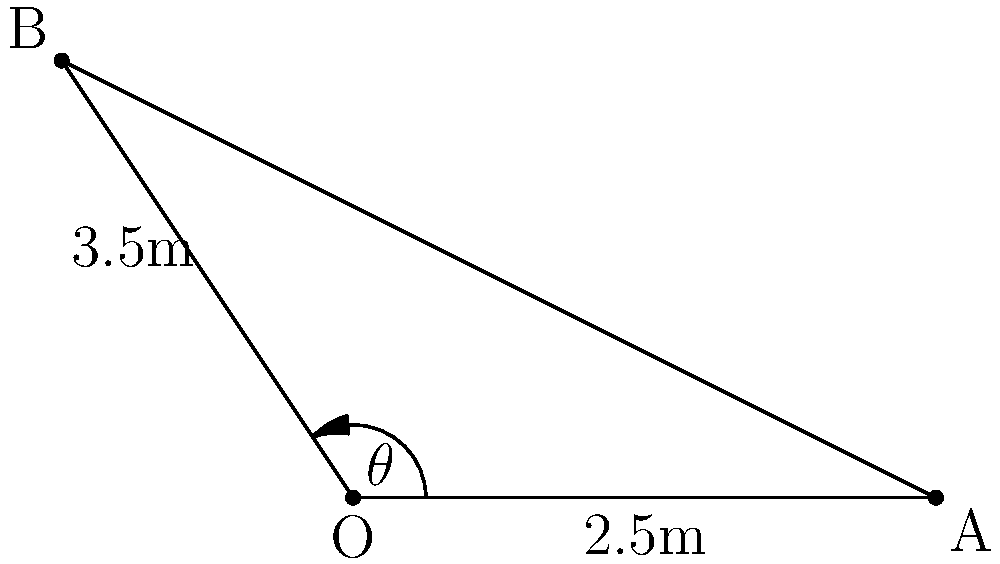In your home audio setup, you're positioning two speakers in a room. Speaker A is placed 2.5m directly in front of the listening position (O), while speaker B is positioned 3.5m away at an angle. If the optimal angle between the speakers is 60°, what should be the distance between the two speakers for ideal sound imaging? To solve this problem, we'll use vector mathematics and the law of cosines. Let's approach this step-by-step:

1) First, let's define our vectors:
   $\vec{OA} = 2.5\hat{i}$
   $\vec{OB} = 3.5(\cos\theta\hat{i} + \sin\theta\hat{j})$

2) We're told that the optimal angle between the speakers is 60°. This means:
   $\theta = 30°$ (half of 60°, as OA is on the x-axis)

3) Now we can fully define $\vec{OB}$:
   $\vec{OB} = 3.5(\cos30°\hat{i} + \sin30°\hat{j})$
              $= 3.5(\frac{\sqrt{3}}{2}\hat{i} + \frac{1}{2}\hat{j})$

4) To find the distance between A and B, we need to find $\vec{AB}$:
   $\vec{AB} = \vec{OB} - \vec{OA}$
              $= (3.5\frac{\sqrt{3}}{2} - 2.5)\hat{i} + 3.5\frac{1}{2}\hat{j}$

5) The distance AB is the magnitude of this vector:
   $AB = \sqrt{(3.5\frac{\sqrt{3}}{2} - 2.5)^2 + (3.5\frac{1}{2})^2}$

6) Simplifying:
   $AB = \sqrt{(3.03 - 2.5)^2 + 1.75^2}$
       $= \sqrt{0.53^2 + 1.75^2}$
       $= \sqrt{0.2809 + 3.0625}$
       $= \sqrt{3.3434}$
       $\approx 1.83$ m

Therefore, the ideal distance between the two speakers is approximately 1.83 meters.
Answer: 1.83 m 